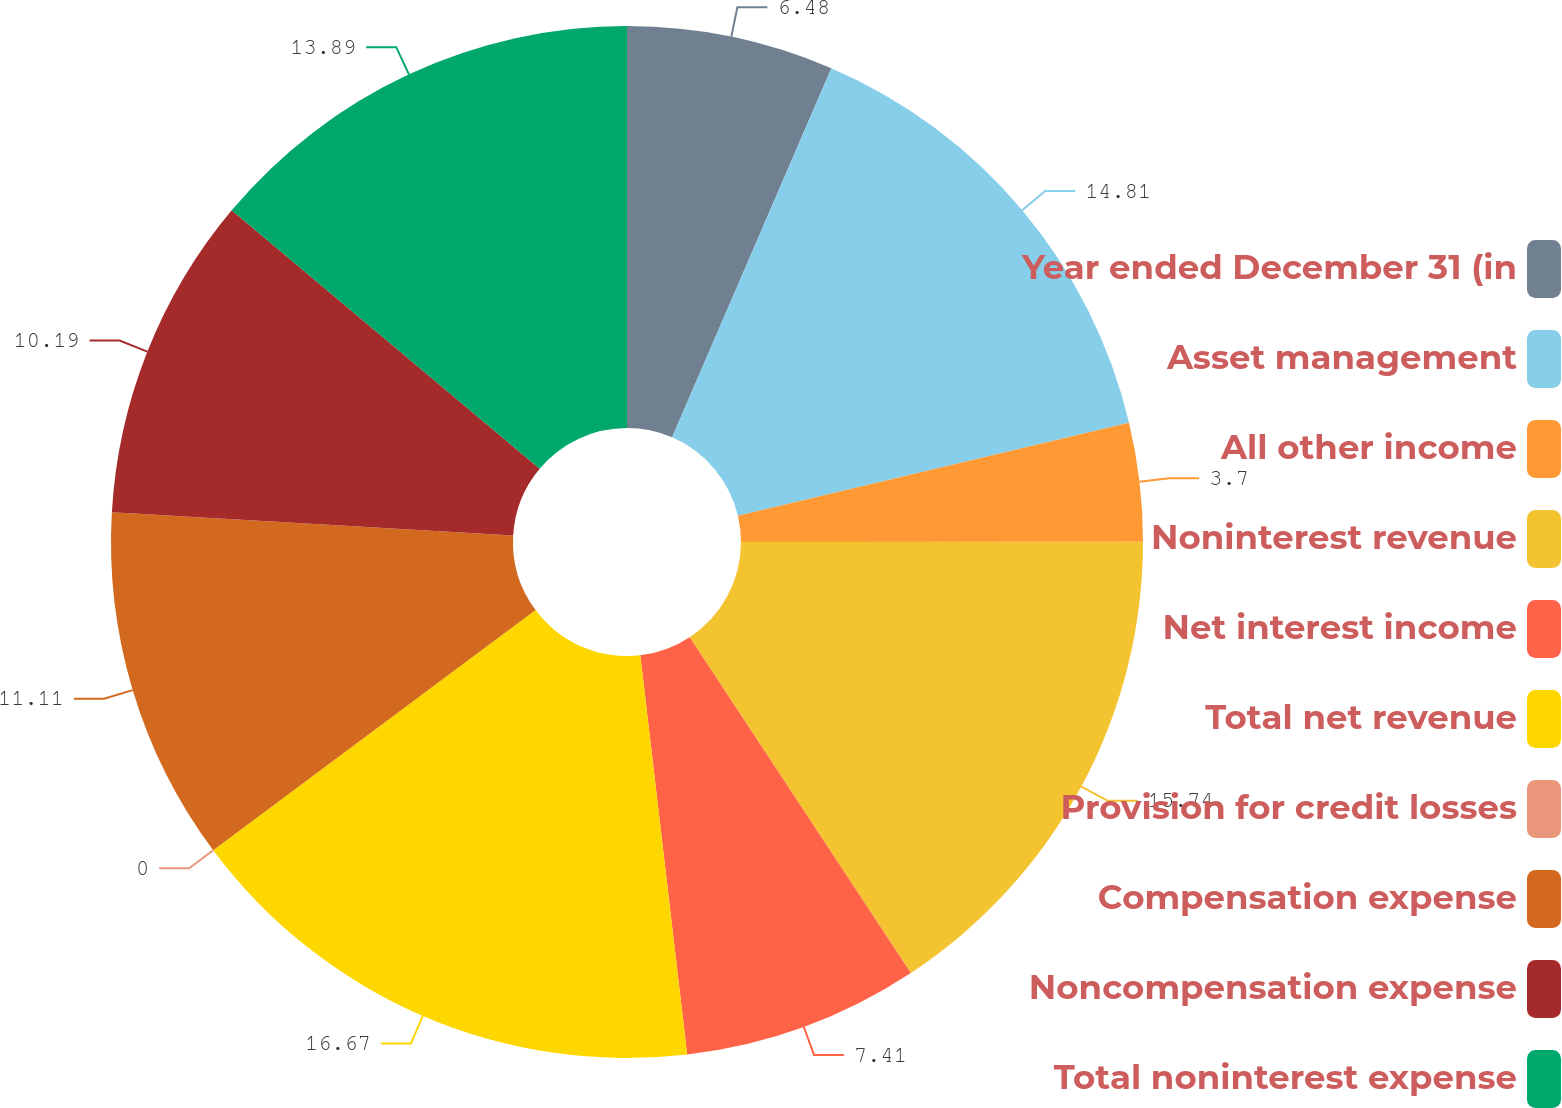<chart> <loc_0><loc_0><loc_500><loc_500><pie_chart><fcel>Year ended December 31 (in<fcel>Asset management<fcel>All other income<fcel>Noninterest revenue<fcel>Net interest income<fcel>Total net revenue<fcel>Provision for credit losses<fcel>Compensation expense<fcel>Noncompensation expense<fcel>Total noninterest expense<nl><fcel>6.48%<fcel>14.81%<fcel>3.7%<fcel>15.74%<fcel>7.41%<fcel>16.67%<fcel>0.0%<fcel>11.11%<fcel>10.19%<fcel>13.89%<nl></chart> 